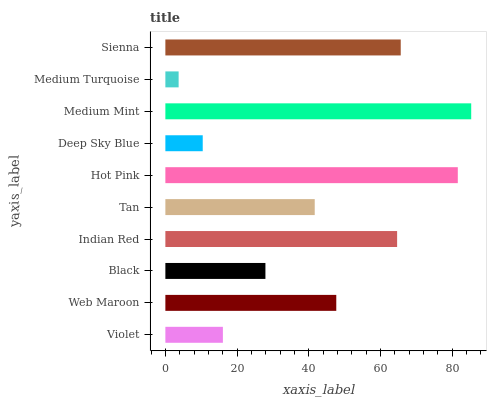Is Medium Turquoise the minimum?
Answer yes or no. Yes. Is Medium Mint the maximum?
Answer yes or no. Yes. Is Web Maroon the minimum?
Answer yes or no. No. Is Web Maroon the maximum?
Answer yes or no. No. Is Web Maroon greater than Violet?
Answer yes or no. Yes. Is Violet less than Web Maroon?
Answer yes or no. Yes. Is Violet greater than Web Maroon?
Answer yes or no. No. Is Web Maroon less than Violet?
Answer yes or no. No. Is Web Maroon the high median?
Answer yes or no. Yes. Is Tan the low median?
Answer yes or no. Yes. Is Medium Turquoise the high median?
Answer yes or no. No. Is Sienna the low median?
Answer yes or no. No. 